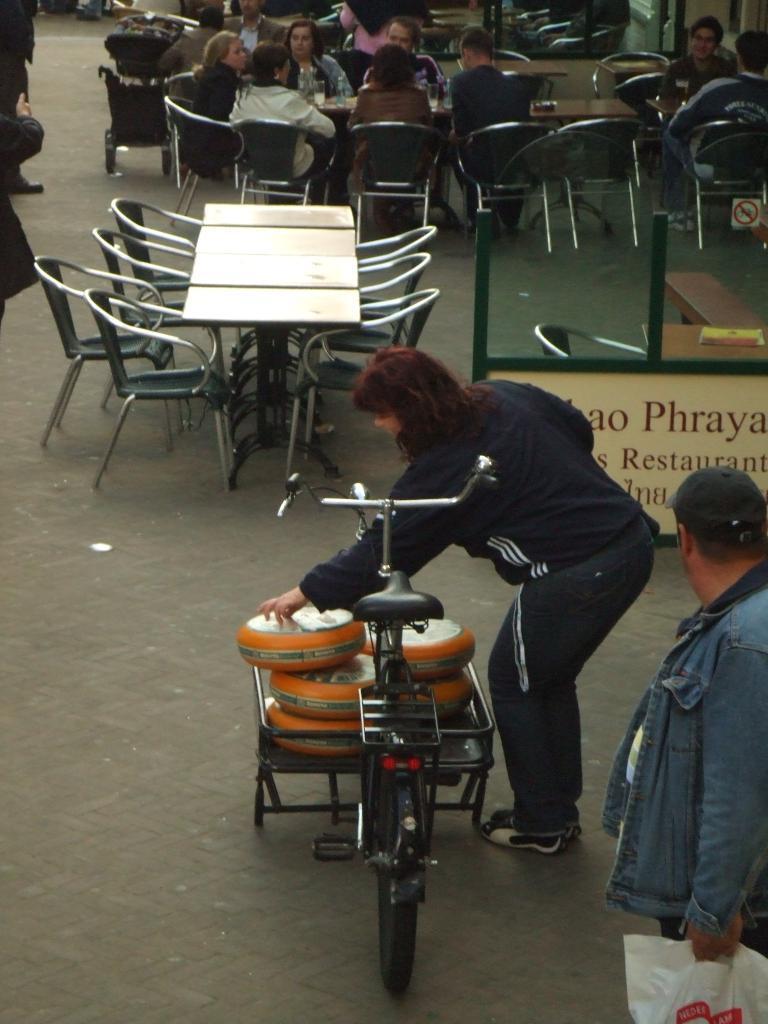Describe this image in one or two sentences. Bottom right side of the image a man is standing and watching. Beside him a person is a standing and holding something. In the middle of the image there is a bicycle. Top left side of the image there are few tables and chairs. Top right side of the image there few people sitting on chairs surrounding the table. Top left side of the image two persons are standing. 